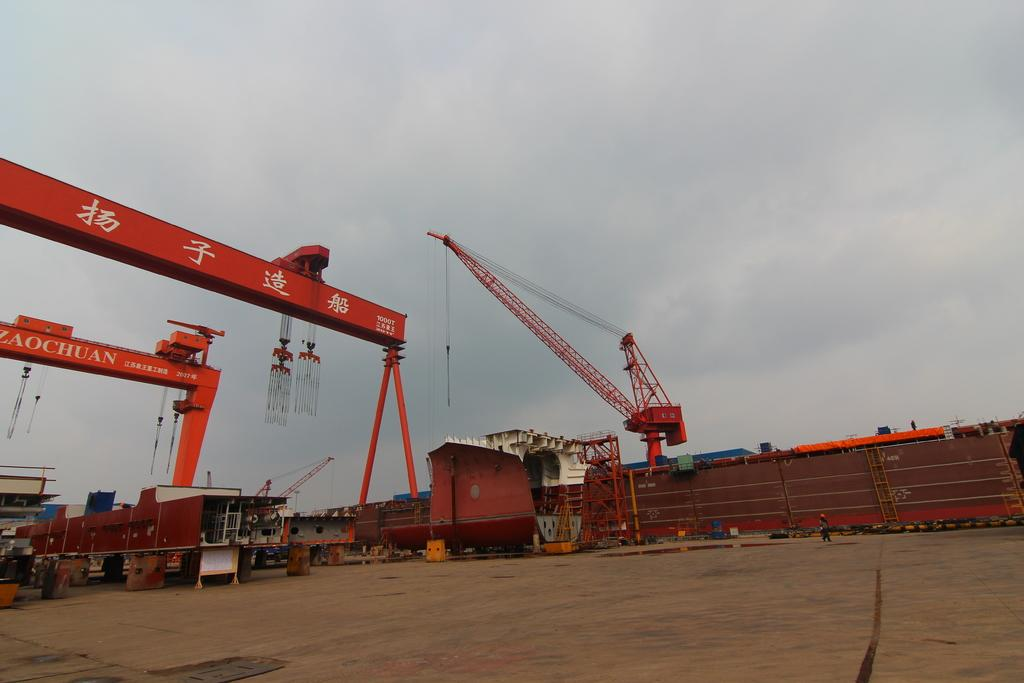What type of view is shown in the image? The image is an outside view. What objects can be seen on the ground in the image? There are metal boxes and cranes on the ground in the image. What is visible at the top of the image? The sky is visible at the top of the image. Can you see any lips in the image? There are no lips present in the image. Is there an office visible in the image? The image does not show an office; it is an outside view with metal boxes and cranes on the ground. 